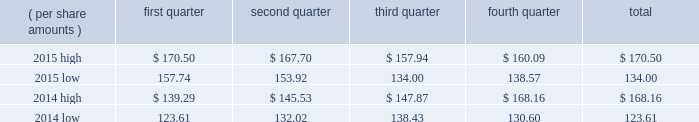Part ii item 5 .
Market for registrant 2019s common equity , related stockholder matters and issuer purchases of equity securities .
Equity compensation plans 2019 information is incorporated by reference from part iii , item 12 , 201csecurity ownership of certain beneficial owners and management and related stockholder matters , 201d of this document , and should be considered an integral part of item 5 .
At january 31 , 2016 , there were 84607 shareholders of record .
3m 2019s stock is listed on the new york stock exchange , inc .
( nyse ) , the chicago stock exchange , inc. , and the swx swiss exchange .
Cash dividends declared and paid totaled $ 1.025 per share for each of the second , third , and fourth quarters of 2015 .
Cash dividends declared in the fourth quarter of 2014 included a dividend paid in november 2014 of $ 0.855 per share and a dividend paid in march 2015 of $ 1.025 per share .
Cash dividends declared and paid totaled $ 0.855 per share for each of the second and third quarters of 2014 .
Cash dividends declared in the fourth quarter of 2013 include a dividend paid in march 2014 of $ 0.855 per share .
Stock price comparisons follow : stock price comparisons ( nyse composite transactions ) .
Issuer purchases of equity securities repurchases of 3m common stock are made to support the company 2019s stock-based employee compensation plans and for other corporate purposes .
In february 2014 , 3m 2019s board of directors authorized the repurchase of up to $ 12 billion of 3m 2019s outstanding common stock , with no pre-established end date .
In february 2016 , 3m 2019s board of directors replaced the company 2019s february 2014 repurchase program with a new repurchase program .
This new program authorizes the repurchase of up to $ 10 billion of 3m 2019s outstanding common stock , with no pre-established end date. .
In february 2016 what was the percent reduction in the board of directors authorized the repurchase to the february 2014? 
Rationale: in 2016 board of directors authorized the repurchase to replace the 2014 amount by 16.7% reduction
Computations: ((10 - 12) / 12)
Answer: -0.16667. 